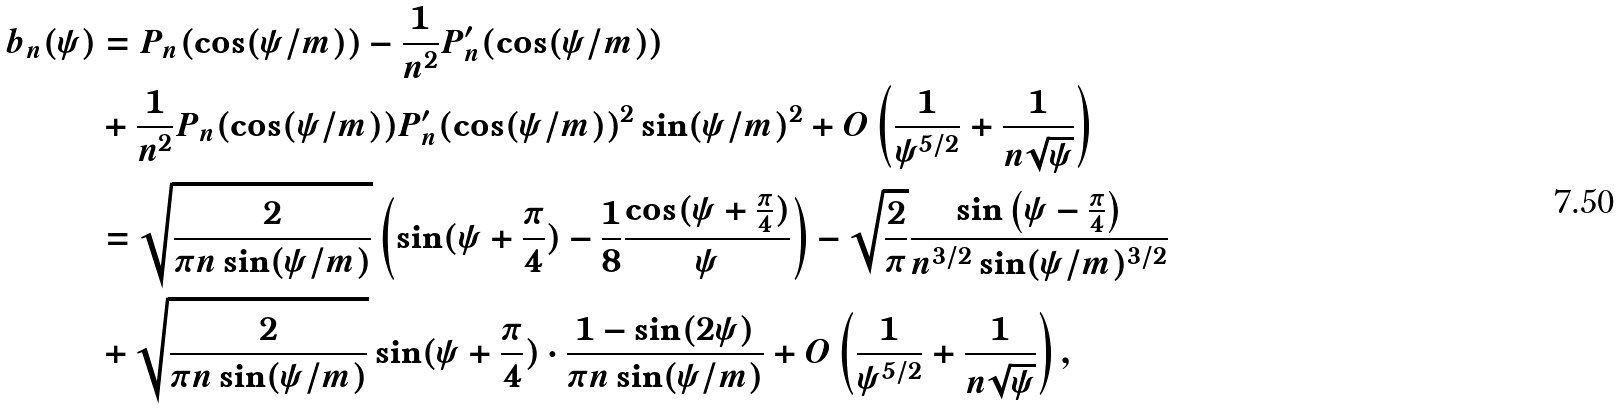Convert formula to latex. <formula><loc_0><loc_0><loc_500><loc_500>b _ { n } ( \psi ) & = P _ { n } ( \cos ( \psi / m ) ) - \frac { 1 } { n ^ { 2 } } P _ { n } ^ { \prime } ( \cos ( \psi / m ) ) \\ & + \frac { 1 } { n ^ { 2 } } P _ { n } ( \cos ( \psi / m ) ) P _ { n } ^ { \prime } ( \cos ( \psi / m ) ) ^ { 2 } \sin ( \psi / m ) ^ { 2 } + O \left ( \frac { 1 } { \psi ^ { 5 / 2 } } + \frac { 1 } { n \sqrt { \psi } } \right ) \\ & = \sqrt { \frac { 2 } { \pi n \sin ( \psi / m ) } } \left ( \sin ( \psi + \frac { \pi } { 4 } ) - \frac { 1 } { 8 } \frac { \cos ( \psi + \frac { \pi } { 4 } ) } { \psi } \right ) - \sqrt { \frac { 2 } { \pi } } \frac { \sin \left ( \psi - \frac { \pi } { 4 } \right ) } { n ^ { 3 / 2 } \sin ( \psi / m ) ^ { 3 / 2 } } \\ & + \sqrt { \frac { 2 } { \pi n \sin ( \psi / m ) } } \sin ( \psi + \frac { \pi } { 4 } ) \cdot \frac { 1 - \sin ( 2 \psi ) } { \pi n \sin ( \psi / m ) } + O \left ( \frac { 1 } { \psi ^ { 5 / 2 } } + \frac { 1 } { n \sqrt { \psi } } \right ) ,</formula> 